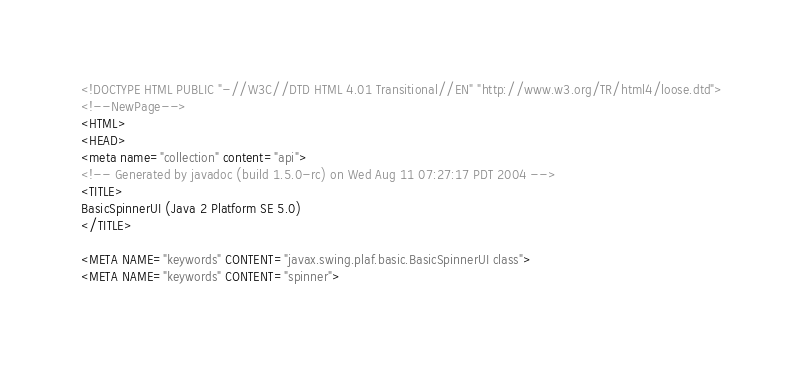Convert code to text. <code><loc_0><loc_0><loc_500><loc_500><_HTML_><!DOCTYPE HTML PUBLIC "-//W3C//DTD HTML 4.01 Transitional//EN" "http://www.w3.org/TR/html4/loose.dtd">
<!--NewPage-->
<HTML>
<HEAD>
<meta name="collection" content="api">
<!-- Generated by javadoc (build 1.5.0-rc) on Wed Aug 11 07:27:17 PDT 2004 -->
<TITLE>
BasicSpinnerUI (Java 2 Platform SE 5.0)
</TITLE>

<META NAME="keywords" CONTENT="javax.swing.plaf.basic.BasicSpinnerUI class">
<META NAME="keywords" CONTENT="spinner"></code> 